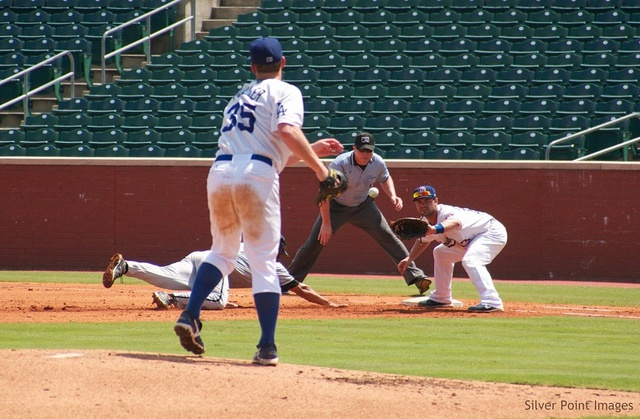Describe the objects in this image and their specific colors. I can see people in gray, darkgray, lavender, and salmon tones, people in gray, white, salmon, maroon, and darkgray tones, people in gray, black, maroon, and brown tones, people in gray, white, and maroon tones, and chair in gray, black, teal, and darkblue tones in this image. 